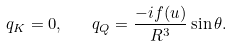<formula> <loc_0><loc_0><loc_500><loc_500>q _ { K } = 0 , \quad q _ { Q } = \frac { - i f ( u ) } { R ^ { 3 } } \sin \theta .</formula> 